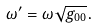<formula> <loc_0><loc_0><loc_500><loc_500>\omega ^ { \prime } & = \omega \sqrt { g _ { 0 0 } } .</formula> 